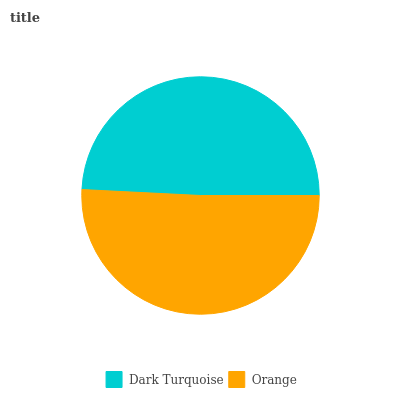Is Dark Turquoise the minimum?
Answer yes or no. Yes. Is Orange the maximum?
Answer yes or no. Yes. Is Orange the minimum?
Answer yes or no. No. Is Orange greater than Dark Turquoise?
Answer yes or no. Yes. Is Dark Turquoise less than Orange?
Answer yes or no. Yes. Is Dark Turquoise greater than Orange?
Answer yes or no. No. Is Orange less than Dark Turquoise?
Answer yes or no. No. Is Orange the high median?
Answer yes or no. Yes. Is Dark Turquoise the low median?
Answer yes or no. Yes. Is Dark Turquoise the high median?
Answer yes or no. No. Is Orange the low median?
Answer yes or no. No. 